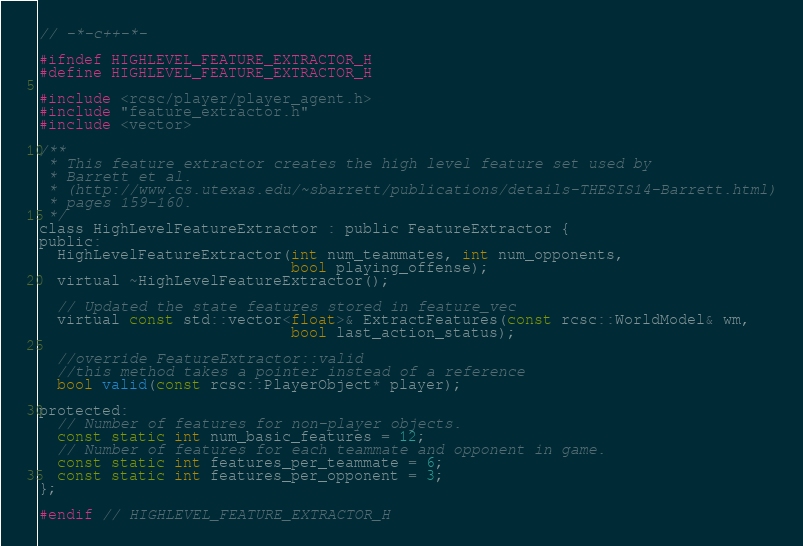Convert code to text. <code><loc_0><loc_0><loc_500><loc_500><_C_>// -*-c++-*-

#ifndef HIGHLEVEL_FEATURE_EXTRACTOR_H
#define HIGHLEVEL_FEATURE_EXTRACTOR_H

#include <rcsc/player/player_agent.h>
#include "feature_extractor.h"
#include <vector>

/**
 * This feature extractor creates the high level feature set used by
 * Barrett et al.
 * (http://www.cs.utexas.edu/~sbarrett/publications/details-THESIS14-Barrett.html)
 * pages 159-160.
 */
class HighLevelFeatureExtractor : public FeatureExtractor {
public:
  HighLevelFeatureExtractor(int num_teammates, int num_opponents,
                            bool playing_offense);
  virtual ~HighLevelFeatureExtractor();

  // Updated the state features stored in feature_vec
  virtual const std::vector<float>& ExtractFeatures(const rcsc::WorldModel& wm,
						    bool last_action_status);

  //override FeatureExtractor::valid
  //this method takes a pointer instead of a reference
  bool valid(const rcsc::PlayerObject* player);

protected:
  // Number of features for non-player objects.
  const static int num_basic_features = 12;
  // Number of features for each teammate and opponent in game.
  const static int features_per_teammate = 6;
  const static int features_per_opponent = 3;
};

#endif // HIGHLEVEL_FEATURE_EXTRACTOR_H
</code> 